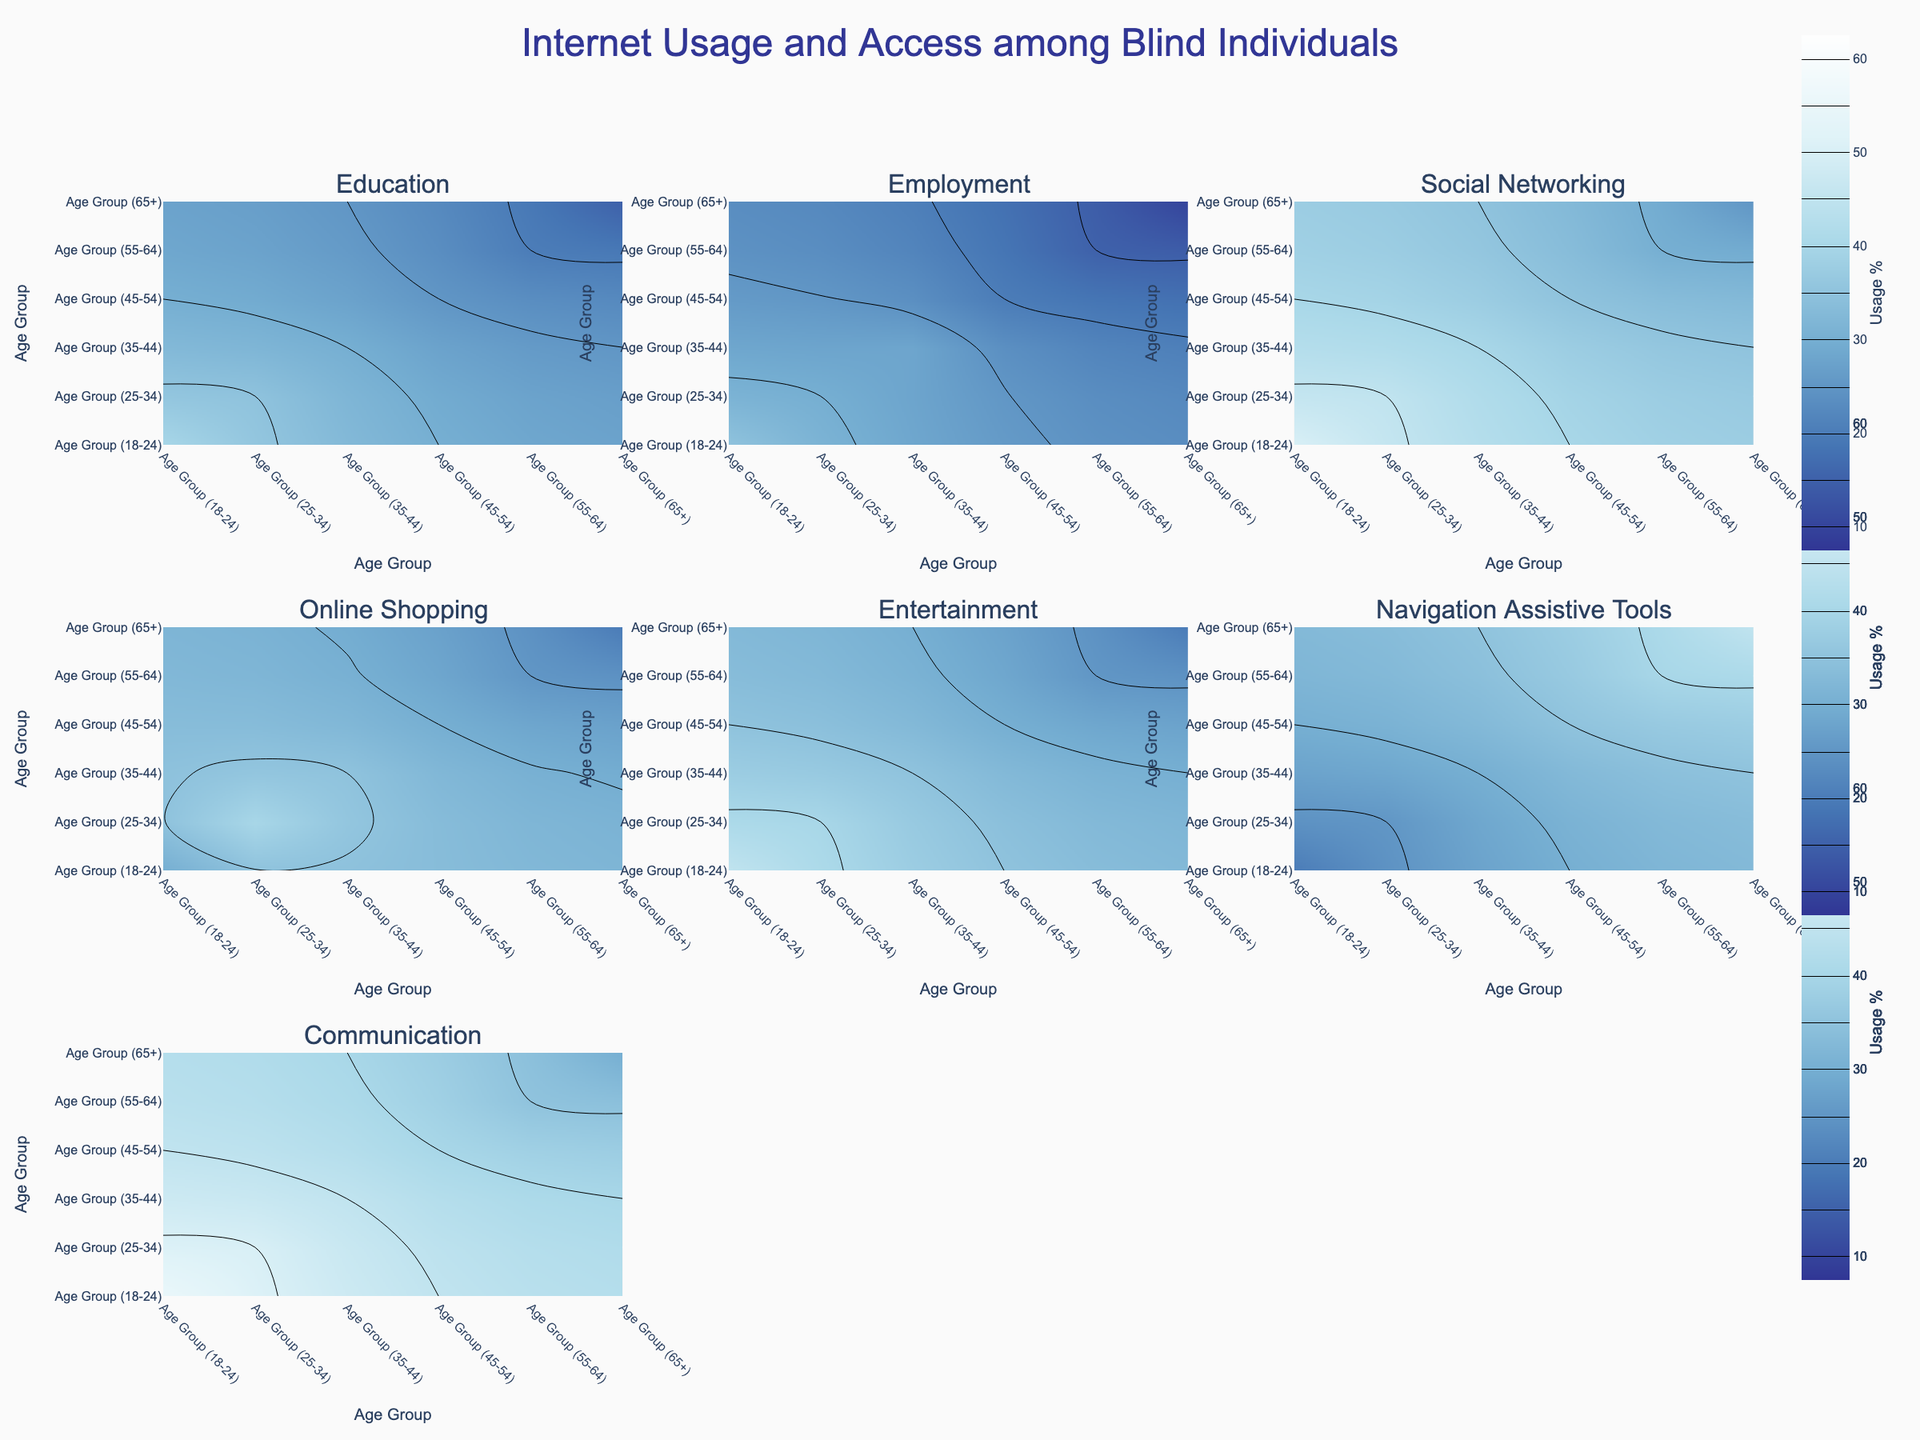What is the title of the plot? The title is located at the top of the figure, centrally aligned. It summarizes the main focus of the plot.
Answer: Internet Usage and Access among Blind Individuals Which age group has the highest percentage for Communication purposes? The maximum value on the Communication contour plot is seen at the age group 18-24. Check the highest point on the corresponding subplot.
Answer: Age Group 18-24 What is the general trend of the usage of Navigation Assistive Tools across age groups? The contour plot for Navigation Assistive Tools shows increasing values from younger to older age groups. The percentages rise as we move from left to right (and bottom to top) on the plot.
Answer: Increasing Which purpose of use shows the highest percentage among all age groups? By comparing the highest percentages of each contour plot, Communication shows the highest peak value at 55%.
Answer: Communication How many subplots are included in the figure? The figure is divided into multiple sections, each representing a different purpose of use. Count the total number of subplots to get the answer.
Answer: 7 subplots For which purpose is the usage among the 45-54 age group higher than the 18-24 age group? By comparing the contour plots, Navigation Assistive Tools plot shows higher usage for the 45-54 age group than the 18-24 age group.
Answer: Navigation Assistive Tools Which age group has the lowest percentage for Employment purposes? By examining the Employment subplot, the age group 65+ shows the lowest usage percentage.
Answer: Age Group 65+ Compare the trend of usage for Online Shopping and Entertainment for age groups 25-34 and 35-44. Which has a steeper decline? By viewing both subplots, compare the drop in percentages between the age groups. Online Shopping shows a smaller decline compared to Entertainment, indicating Entertainment has a steeper decline.
Answer: Entertainment Which age group primarily uses the internet for Education purposes, and how does it change with older age groups? The highest usage for Education purposes is within the 18-24 age group. Usage decreases as we move towards older age groups.
Answer: Age Group 18-24; Decreases What is the range of the color scale in the figure? The color scale is defined from the minimum to the maximum percentage values, which range from 10% to 60%.
Answer: 10% to 60% 